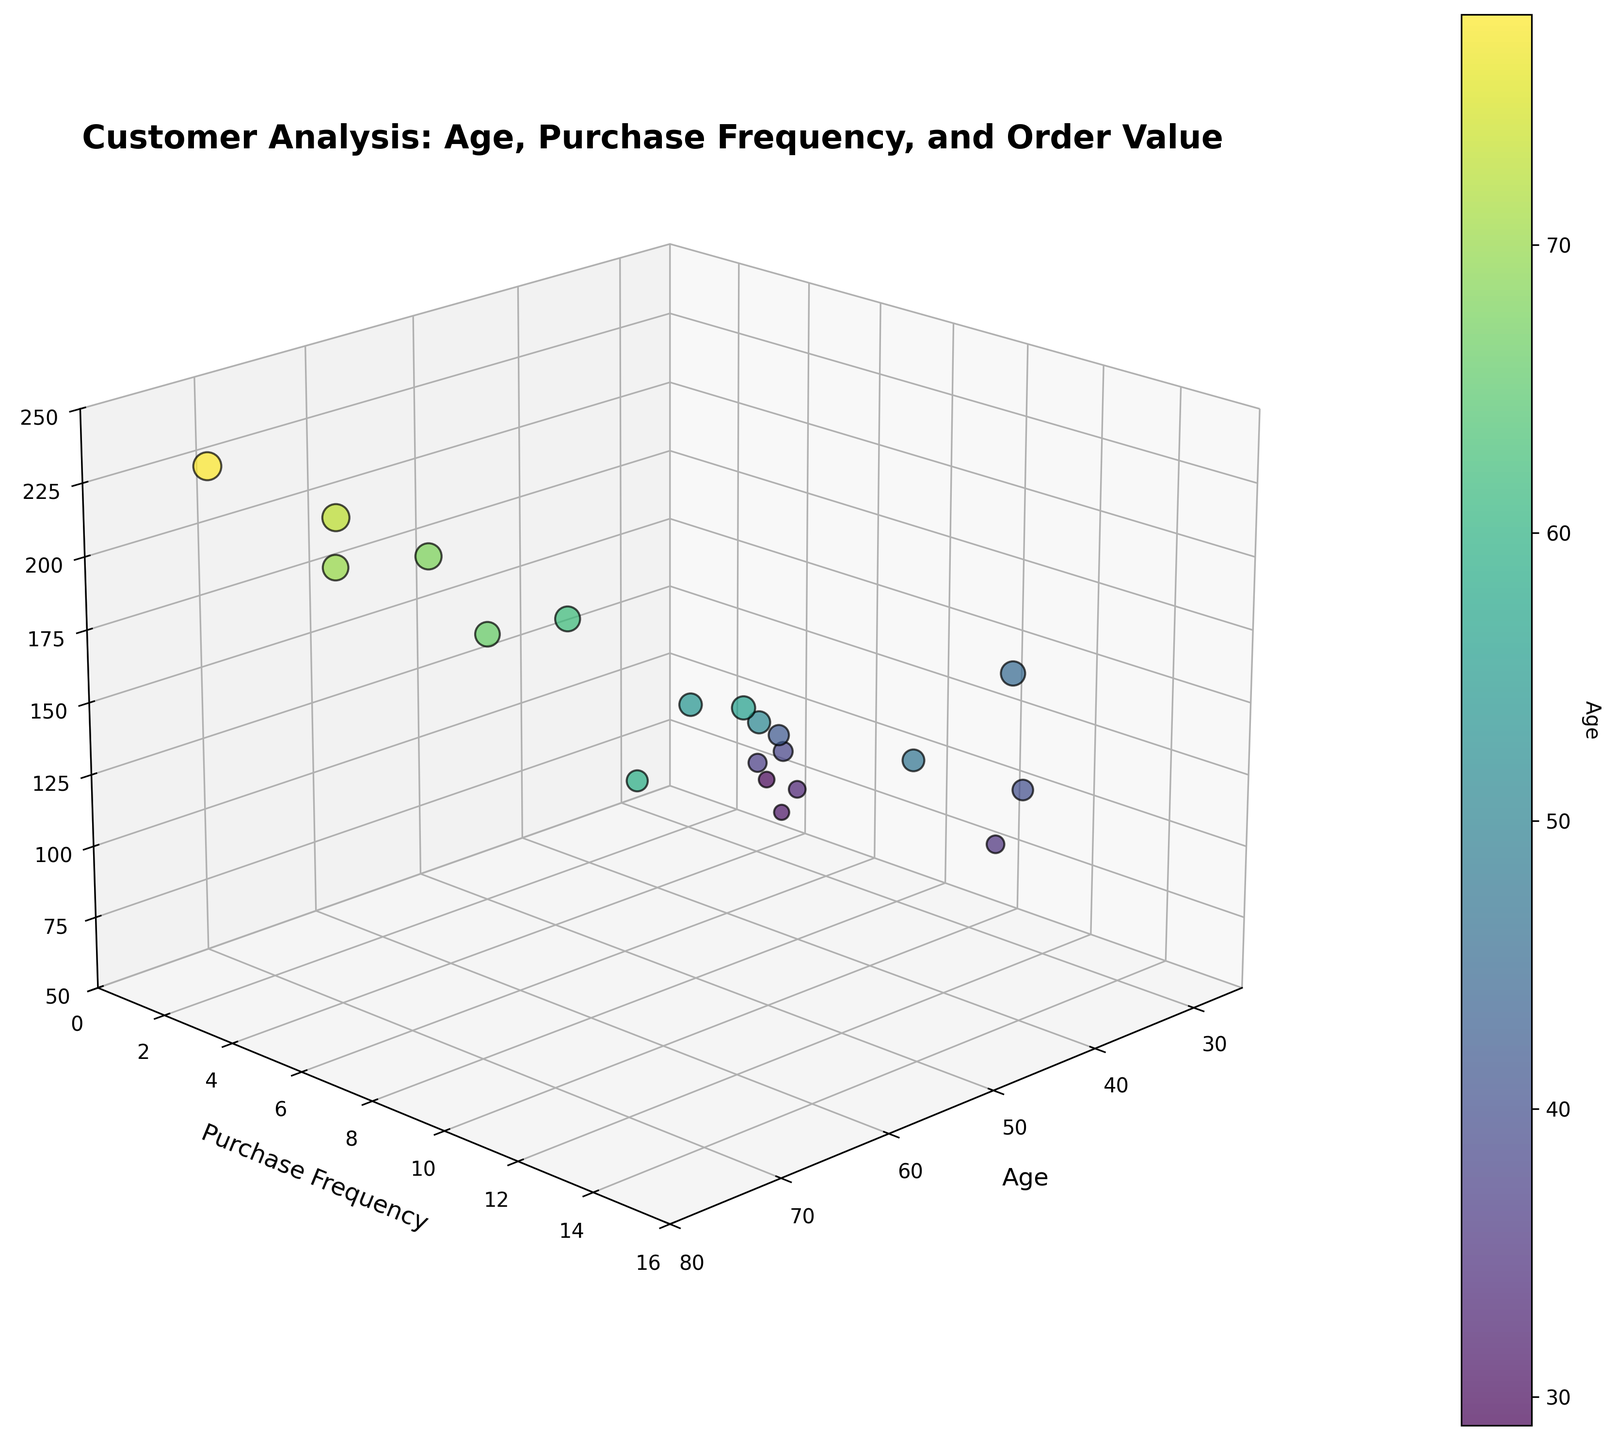What is the range of ages represented in the scatter plot? By looking at the x-axis (Age) and noting the lowest and highest points, we can see that the ages range from 29 to 78.
Answer: 29 to 78 How many customers have an average order value above $200? We examine the z-axis, finding points that have an average order value above $200. There are four such points.
Answer: Four What is the purchase frequency for the youngest customer? By identifying the marker for the youngest customer (age 29) on the x-axis, we move vertically to see the purchase frequency on the y-axis, which is 4.
Answer: 4 Which age group shows the highest average order value in the dataset? The highest point on the z-axis represents the highest average order value ($240.00) and corresponds to an age of 78.
Answer: 78 Is there a general trend between older customers and average order value? Observing the scatter plot, we see that older customers tend to have higher average order values, as shown by the upper right points on the z-axis.
Answer: Yes, older customers generally have higher order values Are there any outliers in purchase frequency for customers around 40 years old? By focusing on the age range around 40 on the x-axis and the corresponding y-axis values, we can identify that a purchase frequency of 12 (Sarah Thompson) stands out.
Answer: Yes, there is an outlier of 12 What is the average purchase frequency for customers above 60 years old? From the plot, identify customers above 60 years old (62, 66, 68, 70, 73, 78). Their purchase frequencies are 8, 7, 6, 4, 5, and 3. Calculate the average: (8 + 7 + 6 + 4 + 5 + 3) / 6 = 5.5.
Answer: 5.5 What is the relationship between purchase frequency and average order value for customers in their 30s? Isolate the points where the age is in the 30s, then examine if higher purchase frequencies correlate with higher or lower average order values. No strong relationship is visible.
Answer: No strong relationship How does the color of the points help in understanding the plot? The color of the points, ranging from yellow to dark purple, represents the age of the customers. This helps to visualize the age distribution and patterns related to other variables like purchase frequency and order value.
Answer: Represents age distribution Which customer group makes the highest purchases but less frequently? From the z-axis (order value) and y-axis (purchase frequency), identify customers with high order values but low purchase frequencies. Customers like Dorothy Wright (78, 240.00, 3) and Patricia Taylor (73, 225.00, 5) fit this pattern.
Answer: Older customers, like Dorothy Wright and Patricia Taylor 